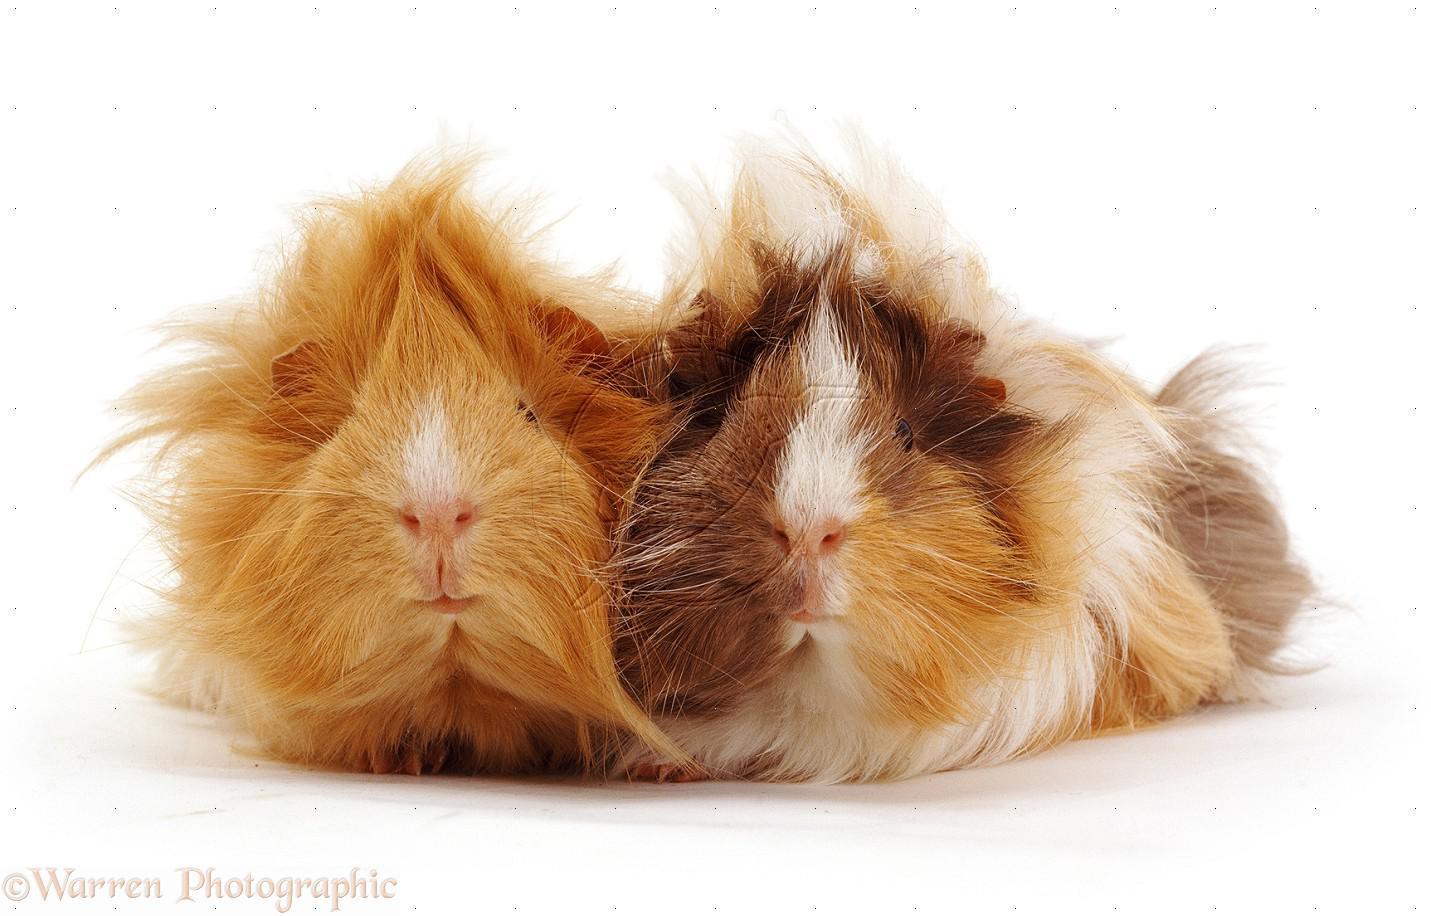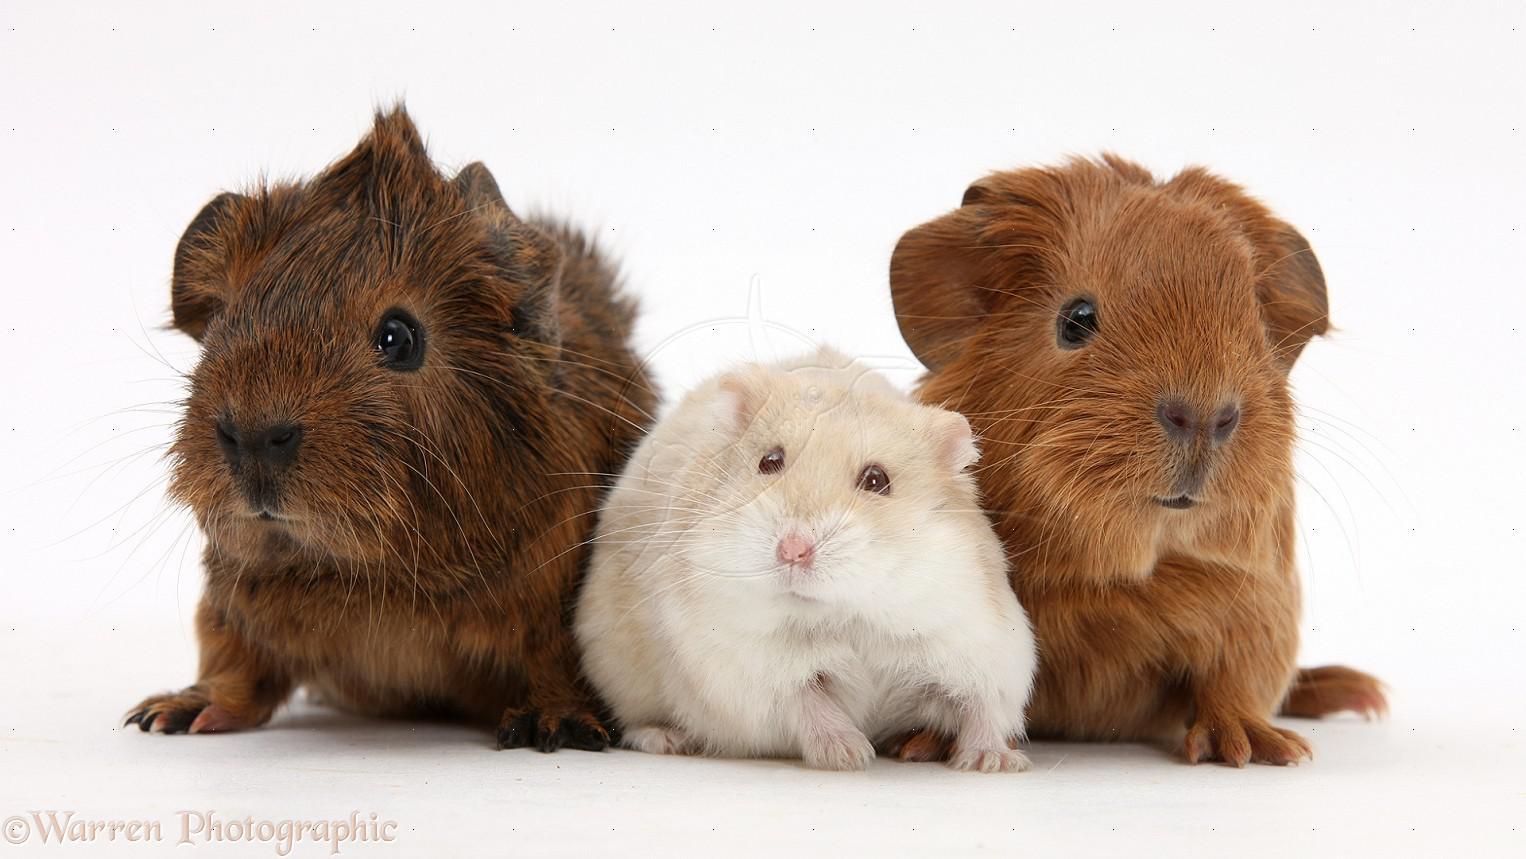The first image is the image on the left, the second image is the image on the right. Considering the images on both sides, is "All of the animals are a type of guinea pig and none of them are sitting on top of each other." valid? Answer yes or no. Yes. The first image is the image on the left, the second image is the image on the right. Analyze the images presented: Is the assertion "The right image has three guinea pigs." valid? Answer yes or no. Yes. 